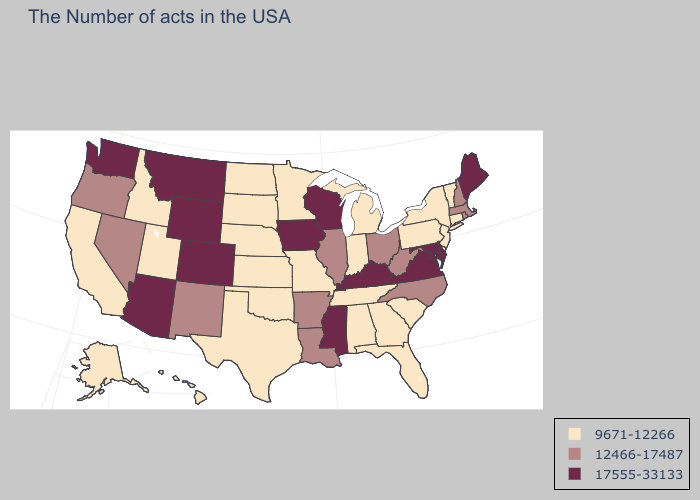What is the value of New York?
Short answer required. 9671-12266. Name the states that have a value in the range 9671-12266?
Give a very brief answer. Vermont, Connecticut, New York, New Jersey, Pennsylvania, South Carolina, Florida, Georgia, Michigan, Indiana, Alabama, Tennessee, Missouri, Minnesota, Kansas, Nebraska, Oklahoma, Texas, South Dakota, North Dakota, Utah, Idaho, California, Alaska, Hawaii. What is the highest value in the USA?
Quick response, please. 17555-33133. Name the states that have a value in the range 12466-17487?
Write a very short answer. Massachusetts, Rhode Island, New Hampshire, North Carolina, West Virginia, Ohio, Illinois, Louisiana, Arkansas, New Mexico, Nevada, Oregon. Does Oklahoma have the highest value in the South?
Be succinct. No. Does Oregon have a higher value than Utah?
Be succinct. Yes. Name the states that have a value in the range 9671-12266?
Be succinct. Vermont, Connecticut, New York, New Jersey, Pennsylvania, South Carolina, Florida, Georgia, Michigan, Indiana, Alabama, Tennessee, Missouri, Minnesota, Kansas, Nebraska, Oklahoma, Texas, South Dakota, North Dakota, Utah, Idaho, California, Alaska, Hawaii. What is the value of Arizona?
Give a very brief answer. 17555-33133. Name the states that have a value in the range 12466-17487?
Keep it brief. Massachusetts, Rhode Island, New Hampshire, North Carolina, West Virginia, Ohio, Illinois, Louisiana, Arkansas, New Mexico, Nevada, Oregon. Among the states that border Nebraska , which have the highest value?
Give a very brief answer. Iowa, Wyoming, Colorado. Does Minnesota have the highest value in the MidWest?
Be succinct. No. What is the value of Oregon?
Quick response, please. 12466-17487. What is the value of Vermont?
Answer briefly. 9671-12266. Is the legend a continuous bar?
Short answer required. No. Does Utah have the lowest value in the USA?
Keep it brief. Yes. 